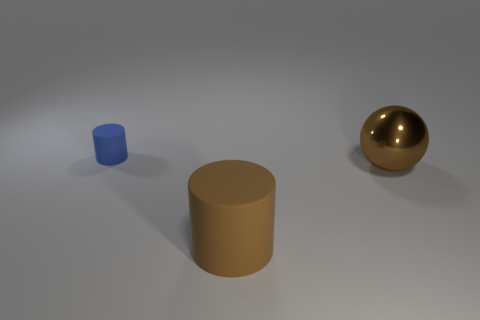Add 3 tiny matte spheres. How many objects exist? 6 Subtract all cylinders. How many objects are left? 1 Subtract 1 balls. How many balls are left? 0 Add 2 small green matte blocks. How many small green matte blocks exist? 2 Subtract 0 gray blocks. How many objects are left? 3 Subtract all gray cylinders. Subtract all red blocks. How many cylinders are left? 2 Subtract all red cubes. How many red cylinders are left? 0 Subtract all green metal things. Subtract all brown things. How many objects are left? 1 Add 2 cylinders. How many cylinders are left? 4 